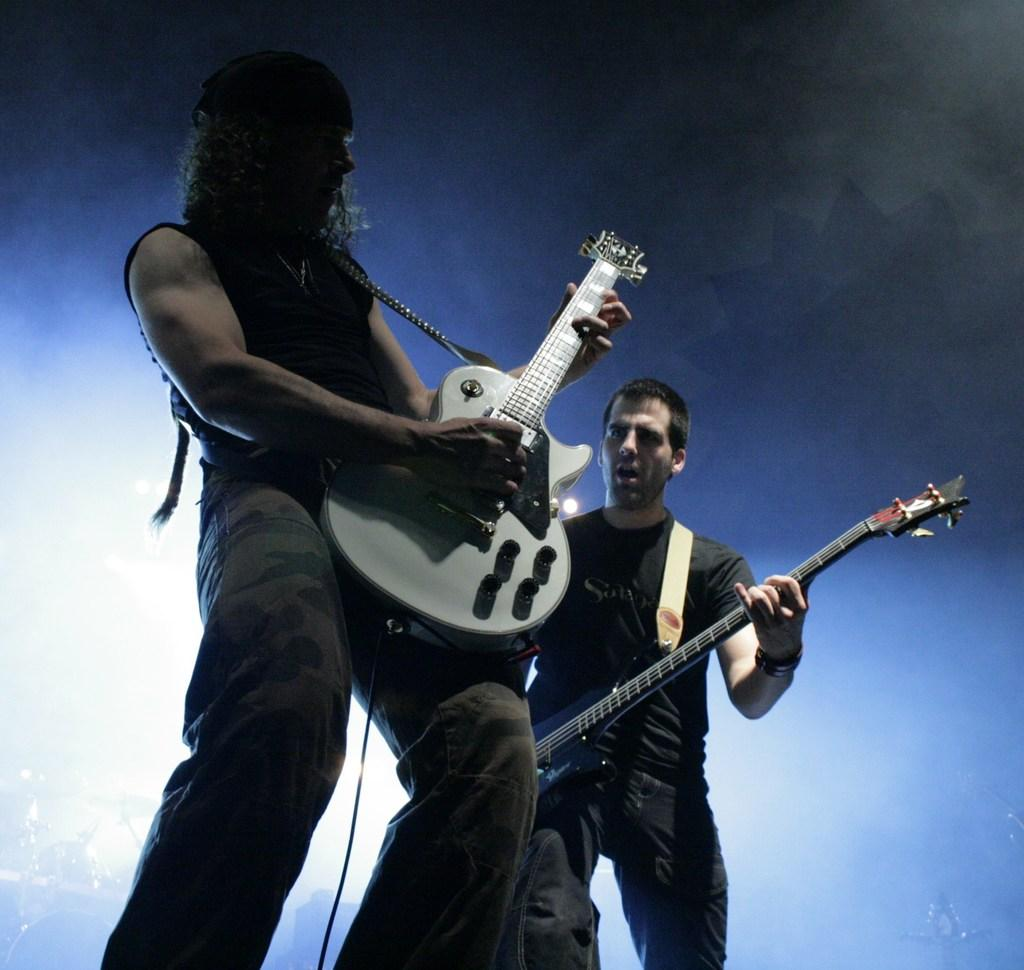How many people are in the image? There are two persons in the image. What are the persons doing in the image? The persons are standing, and one of them is playing a guitar. What can be seen in the background of the image? The background of the image is dark, but there is light visible in the background. What type of drink is being shared between the two persons in the image? There is no drink present in the image; it only shows two persons, one of whom is playing a guitar. What type of oil is visible on the guitar strings in the image? There is no oil visible on the guitar strings in the image; it only shows a person playing a guitar. 